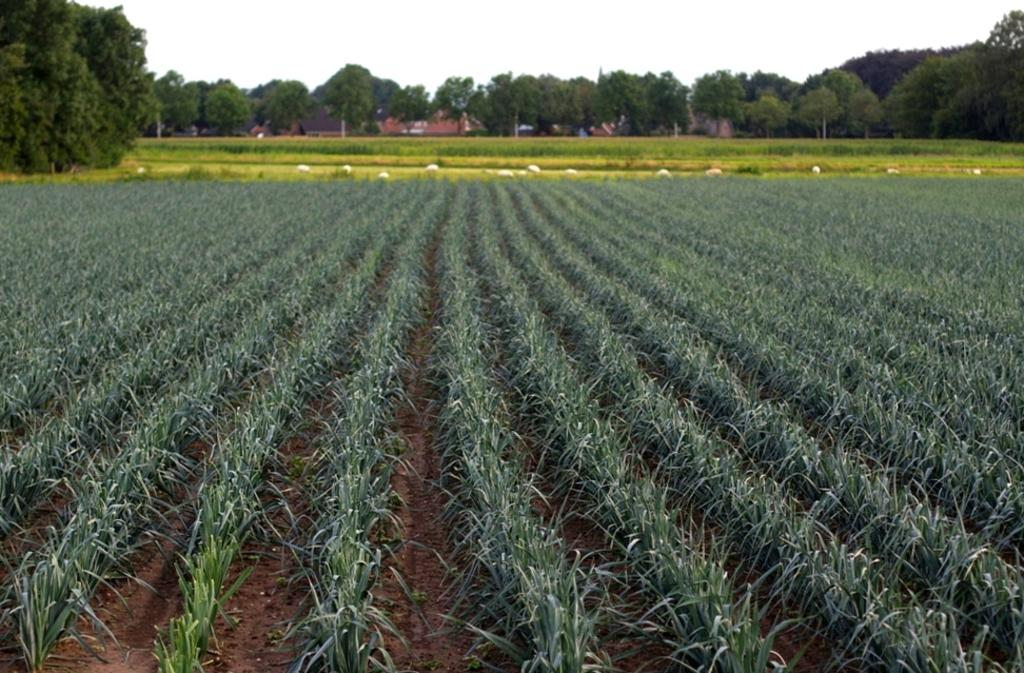What type of vegetation can be seen in the image? There are plants and trees visible in the image. What type of ground cover can be seen in the image? There is grass visible in the image. What part of the natural environment is visible in the image? The sky is visible in the image. What type of cabbage is growing on the wall in the image? There is no cabbage or wall present in the image. What stage of development are the plants in the image? The provided facts do not give information about the development stage of the plants in the image. 